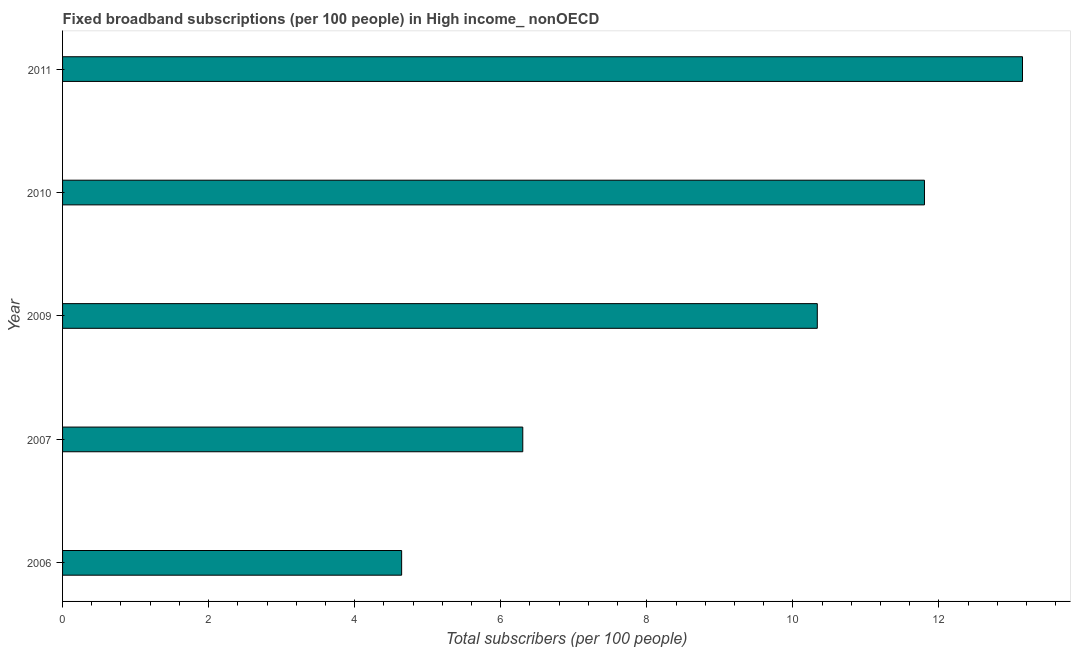What is the title of the graph?
Ensure brevity in your answer.  Fixed broadband subscriptions (per 100 people) in High income_ nonOECD. What is the label or title of the X-axis?
Provide a succinct answer. Total subscribers (per 100 people). What is the label or title of the Y-axis?
Provide a short and direct response. Year. What is the total number of fixed broadband subscriptions in 2006?
Offer a very short reply. 4.64. Across all years, what is the maximum total number of fixed broadband subscriptions?
Provide a short and direct response. 13.14. Across all years, what is the minimum total number of fixed broadband subscriptions?
Your answer should be very brief. 4.64. In which year was the total number of fixed broadband subscriptions maximum?
Provide a short and direct response. 2011. In which year was the total number of fixed broadband subscriptions minimum?
Provide a succinct answer. 2006. What is the sum of the total number of fixed broadband subscriptions?
Ensure brevity in your answer.  46.22. What is the difference between the total number of fixed broadband subscriptions in 2010 and 2011?
Your answer should be very brief. -1.34. What is the average total number of fixed broadband subscriptions per year?
Your answer should be compact. 9.24. What is the median total number of fixed broadband subscriptions?
Your answer should be compact. 10.33. In how many years, is the total number of fixed broadband subscriptions greater than 8.4 ?
Offer a terse response. 3. What is the ratio of the total number of fixed broadband subscriptions in 2006 to that in 2011?
Ensure brevity in your answer.  0.35. Is the total number of fixed broadband subscriptions in 2009 less than that in 2011?
Provide a short and direct response. Yes. What is the difference between the highest and the second highest total number of fixed broadband subscriptions?
Provide a short and direct response. 1.34. Is the sum of the total number of fixed broadband subscriptions in 2007 and 2010 greater than the maximum total number of fixed broadband subscriptions across all years?
Keep it short and to the point. Yes. What is the difference between the highest and the lowest total number of fixed broadband subscriptions?
Your response must be concise. 8.5. In how many years, is the total number of fixed broadband subscriptions greater than the average total number of fixed broadband subscriptions taken over all years?
Make the answer very short. 3. How many bars are there?
Provide a succinct answer. 5. What is the Total subscribers (per 100 people) of 2006?
Provide a succinct answer. 4.64. What is the Total subscribers (per 100 people) in 2007?
Ensure brevity in your answer.  6.3. What is the Total subscribers (per 100 people) of 2009?
Your answer should be compact. 10.33. What is the Total subscribers (per 100 people) of 2010?
Your answer should be compact. 11.8. What is the Total subscribers (per 100 people) of 2011?
Provide a short and direct response. 13.14. What is the difference between the Total subscribers (per 100 people) in 2006 and 2007?
Your answer should be compact. -1.66. What is the difference between the Total subscribers (per 100 people) in 2006 and 2009?
Your answer should be compact. -5.69. What is the difference between the Total subscribers (per 100 people) in 2006 and 2010?
Offer a terse response. -7.16. What is the difference between the Total subscribers (per 100 people) in 2006 and 2011?
Your answer should be compact. -8.5. What is the difference between the Total subscribers (per 100 people) in 2007 and 2009?
Offer a terse response. -4.03. What is the difference between the Total subscribers (per 100 people) in 2007 and 2010?
Your response must be concise. -5.5. What is the difference between the Total subscribers (per 100 people) in 2007 and 2011?
Your answer should be very brief. -6.84. What is the difference between the Total subscribers (per 100 people) in 2009 and 2010?
Your response must be concise. -1.47. What is the difference between the Total subscribers (per 100 people) in 2009 and 2011?
Offer a very short reply. -2.81. What is the difference between the Total subscribers (per 100 people) in 2010 and 2011?
Your answer should be compact. -1.34. What is the ratio of the Total subscribers (per 100 people) in 2006 to that in 2007?
Your answer should be compact. 0.74. What is the ratio of the Total subscribers (per 100 people) in 2006 to that in 2009?
Offer a very short reply. 0.45. What is the ratio of the Total subscribers (per 100 people) in 2006 to that in 2010?
Give a very brief answer. 0.39. What is the ratio of the Total subscribers (per 100 people) in 2006 to that in 2011?
Provide a short and direct response. 0.35. What is the ratio of the Total subscribers (per 100 people) in 2007 to that in 2009?
Make the answer very short. 0.61. What is the ratio of the Total subscribers (per 100 people) in 2007 to that in 2010?
Give a very brief answer. 0.53. What is the ratio of the Total subscribers (per 100 people) in 2007 to that in 2011?
Provide a succinct answer. 0.48. What is the ratio of the Total subscribers (per 100 people) in 2009 to that in 2010?
Offer a very short reply. 0.88. What is the ratio of the Total subscribers (per 100 people) in 2009 to that in 2011?
Make the answer very short. 0.79. What is the ratio of the Total subscribers (per 100 people) in 2010 to that in 2011?
Provide a succinct answer. 0.9. 